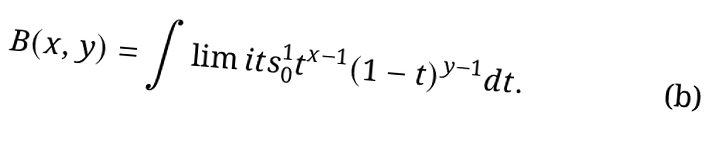Convert formula to latex. <formula><loc_0><loc_0><loc_500><loc_500>B ( x , y ) = \int \lim i t s _ { 0 } ^ { 1 } t ^ { x - 1 } ( 1 - t ) ^ { y - 1 } d t .</formula> 